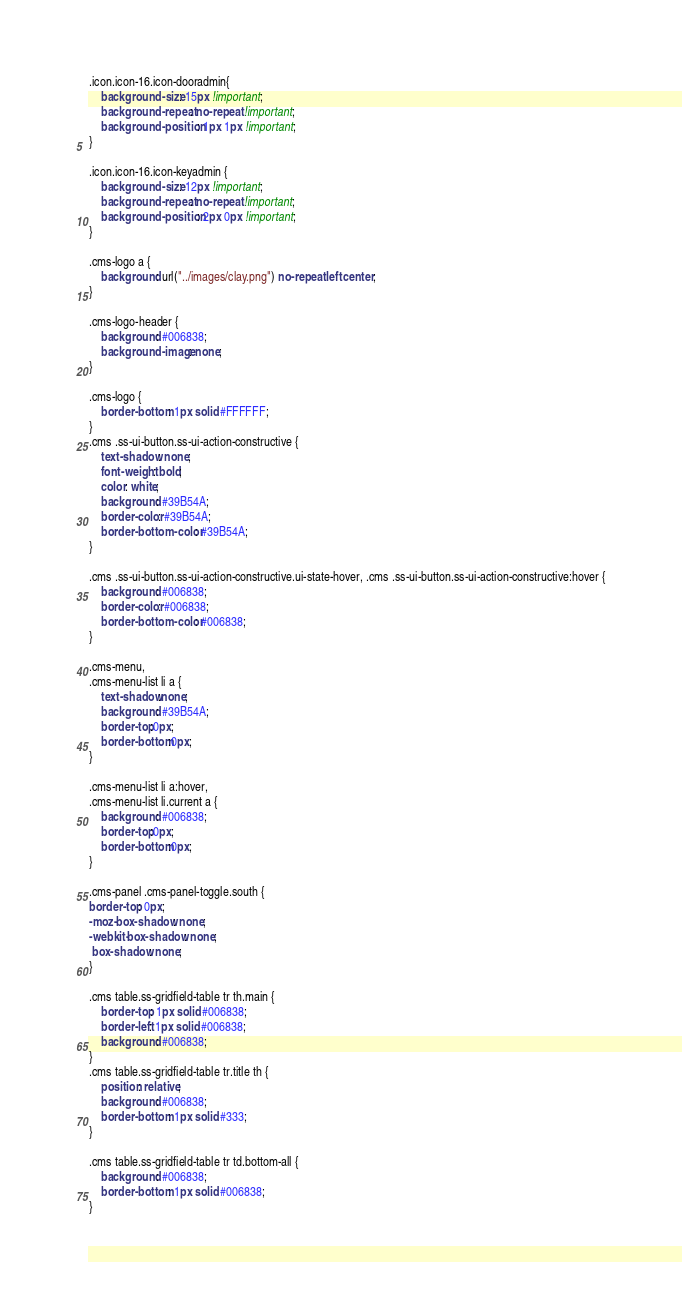<code> <loc_0><loc_0><loc_500><loc_500><_CSS_>.icon.icon-16.icon-dooradmin{
	background-size: 15px !important;
	background-repeat: no-repeat !important;
	background-position: 1px 1px !important;
}

.icon.icon-16.icon-keyadmin {
	background-size: 12px !important;
	background-repeat: no-repeat !important;
	background-position: 2px 0px !important;
}

.cms-logo a {
    background: url("../images/clay.png") no-repeat left center;
}

.cms-logo-header {
	background: #006838;
	background-image: none;
}

.cms-logo {
	border-bottom: 1px solid #FFFFFF;
}
.cms .ss-ui-button.ss-ui-action-constructive {
	text-shadow: none;
	font-weight: bold;
	color: white;
	background: #39B54A;
	border-color: #39B54A;
	border-bottom-color: #39B54A;
}

.cms .ss-ui-button.ss-ui-action-constructive.ui-state-hover, .cms .ss-ui-button.ss-ui-action-constructive:hover {
	background: #006838;
	border-color: #006838;
	border-bottom-color: #006838;
}

.cms-menu,
.cms-menu-list li a {
	text-shadow:none;
	background: #39B54A;
	border-top:0px;
	border-bottom:0px;
}

.cms-menu-list li a:hover,
.cms-menu-list li.current a {
	background: #006838;
	border-top:0px;
	border-bottom:0px;
}

.cms-panel .cms-panel-toggle.south {
border-top: 0px;
-moz-box-shadow: none;
-webkit-box-shadow: none;
 box-shadow: none;
}

.cms table.ss-gridfield-table tr th.main {
	border-top: 1px solid #006838;
	border-left: 1px solid #006838;
	background: #006838;
}
.cms table.ss-gridfield-table tr.title th {
	position: relative;
	background: #006838;
	border-bottom: 1px solid #333;
}

.cms table.ss-gridfield-table tr td.bottom-all {
	background: #006838;
	border-bottom: 1px solid #006838;
}</code> 